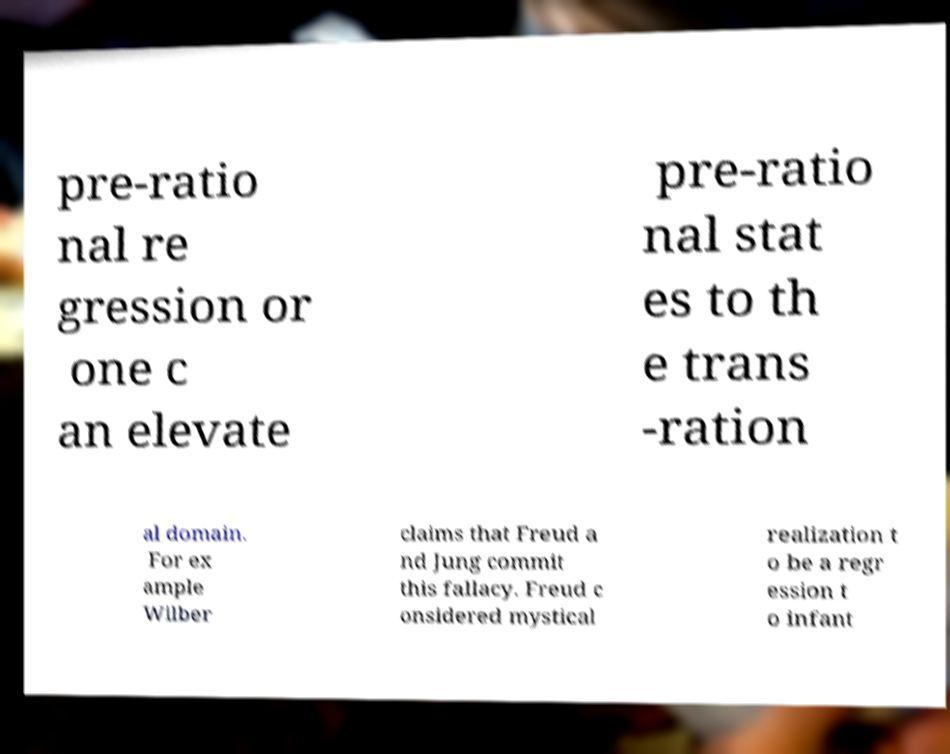Can you accurately transcribe the text from the provided image for me? pre-ratio nal re gression or one c an elevate pre-ratio nal stat es to th e trans -ration al domain. For ex ample Wilber claims that Freud a nd Jung commit this fallacy. Freud c onsidered mystical realization t o be a regr ession t o infant 